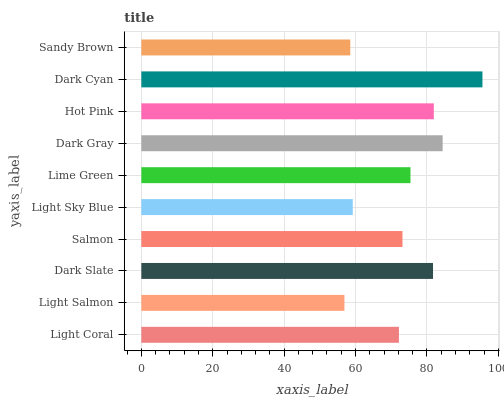Is Light Salmon the minimum?
Answer yes or no. Yes. Is Dark Cyan the maximum?
Answer yes or no. Yes. Is Dark Slate the minimum?
Answer yes or no. No. Is Dark Slate the maximum?
Answer yes or no. No. Is Dark Slate greater than Light Salmon?
Answer yes or no. Yes. Is Light Salmon less than Dark Slate?
Answer yes or no. Yes. Is Light Salmon greater than Dark Slate?
Answer yes or no. No. Is Dark Slate less than Light Salmon?
Answer yes or no. No. Is Lime Green the high median?
Answer yes or no. Yes. Is Salmon the low median?
Answer yes or no. Yes. Is Sandy Brown the high median?
Answer yes or no. No. Is Lime Green the low median?
Answer yes or no. No. 